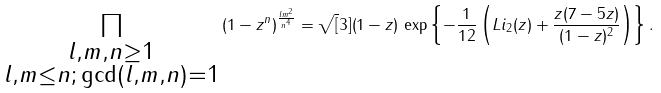Convert formula to latex. <formula><loc_0><loc_0><loc_500><loc_500>\prod _ { \substack { l , m , n \geq 1 \\ l , m \leq n ; \, \gcd ( l , m , n ) = 1 } } \left ( 1 - z ^ { n } \right ) ^ { \frac { l m ^ { 2 } } { n ^ { 4 } } } = \sqrt { [ } 3 ] { \left ( 1 - z \right ) } \, \exp \left \{ - \frac { 1 } { 1 2 } \left ( L i _ { 2 } ( z ) + \frac { z ( 7 - 5 z ) } { ( 1 - z ) ^ { 2 } } \right ) \right \} .</formula> 